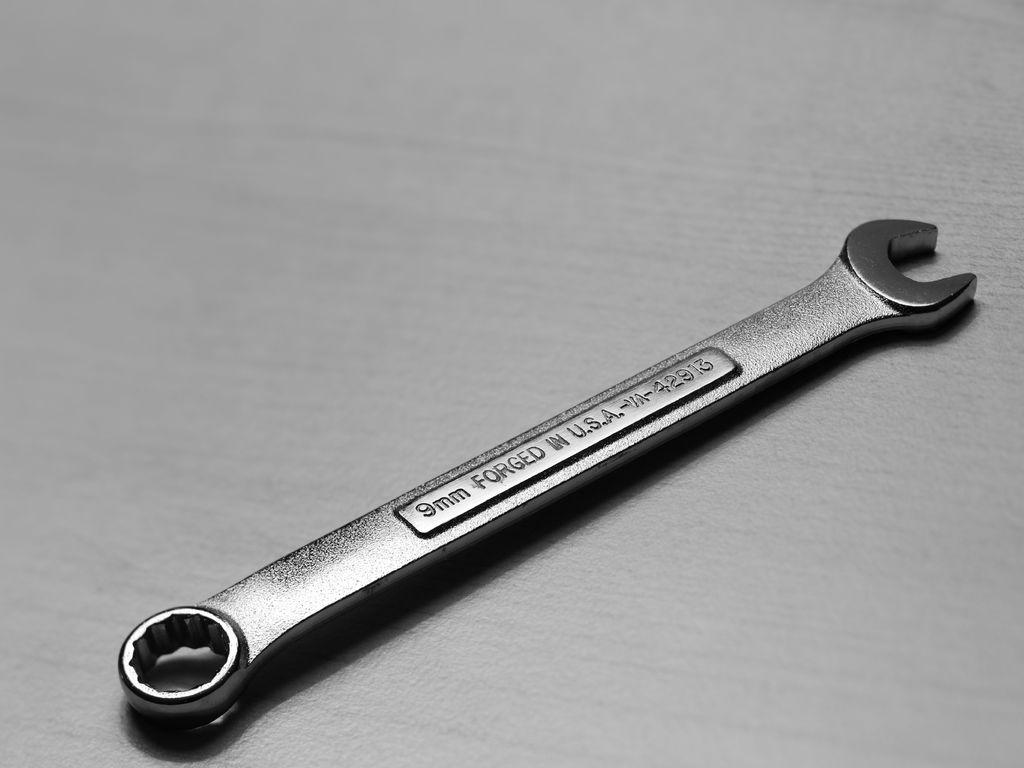What tool is present in the image? There is a spanner in the image. Can you provide any details about the spanner's size? Yes, the spanner is 9mm in size. What book is the spanner reading in the image? There is no book present in the image, and the spanner is an inanimate object, so it cannot read. 